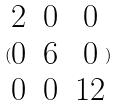<formula> <loc_0><loc_0><loc_500><loc_500>( \begin{matrix} 2 & 0 & 0 \\ 0 & 6 & 0 \\ 0 & 0 & 1 2 \end{matrix} )</formula> 